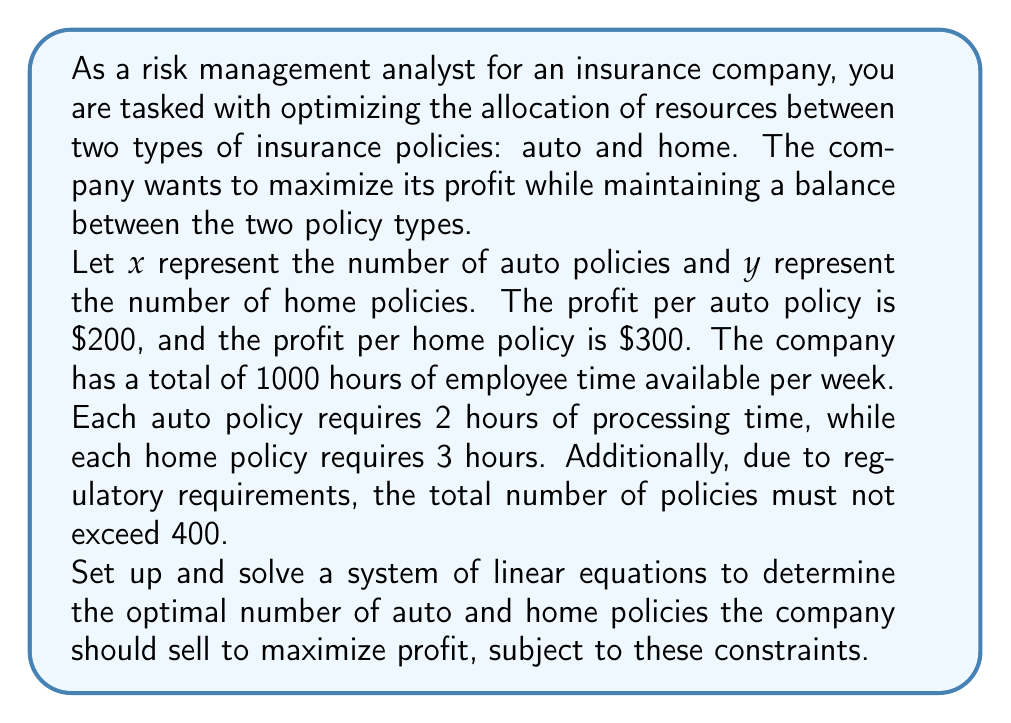Solve this math problem. To solve this optimization problem, we need to set up a system of linear equations and inequalities based on the given constraints, and then maximize the profit function.

1. Let's define our constraints:

   a. Time constraint: $2x + 3y \leq 1000$ (total processing time ≤ available time)
   b. Policy limit constraint: $x + y \leq 400$ (total policies ≤ 400)
   c. Non-negativity constraints: $x \geq 0, y \geq 0$

2. Our objective function (profit) is:
   $P = 200x + 300y$ (to be maximized)

3. To solve this linear programming problem, we can use the corner point method. The optimal solution will be at one of the corner points of the feasible region defined by our constraints.

4. Find the corner points by solving the equations:
   - $(0, 0)$ : Trivial solution
   - $(400, 0)$ : From $x + y = 400$ and $y = 0$
   - $(0, 333.33)$ : From $3y = 1000$ and $x = 0$
   - Intersection of $2x + 3y = 1000$ and $x + y = 400$:
     Solving these simultaneously:
     $2x + 3y = 1000$
     $x + y = 400$
     
     Subtracting the second equation from the first:
     $x + 2y = 600$
     $x = 400 - y$
     
     Substituting:
     $2(400 - y) + 3y = 1000$
     $800 - 2y + 3y = 1000$
     $y = 200$
     $x = 200$

     So, the fourth corner point is $(200, 200)$

5. Evaluate the profit function at each corner point:
   $P(0, 0) = 0$
   $P(400, 0) = 80,000$
   $P(0, 333.33) = 99,999$
   $P(200, 200) = 100,000$

6. The maximum profit occurs at the point $(200, 200)$, which satisfies all constraints.

Therefore, the optimal allocation is 200 auto policies and 200 home policies.
Answer: The optimal allocation to maximize profit is 200 auto policies and 200 home policies, resulting in a maximum profit of $\$100,000$. 